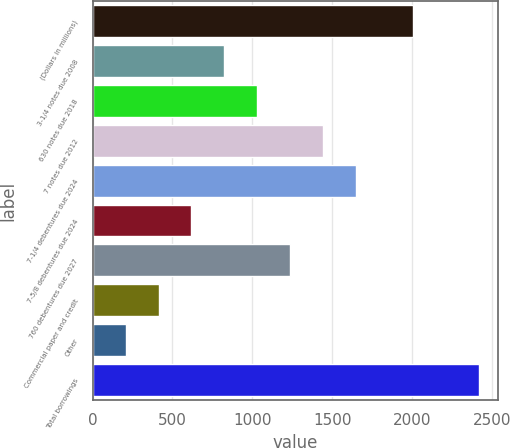<chart> <loc_0><loc_0><loc_500><loc_500><bar_chart><fcel>(Dollars in millions)<fcel>3-1/4 notes due 2008<fcel>630 notes due 2018<fcel>7 notes due 2012<fcel>7-1/4 debentures due 2024<fcel>7-5/8 debentures due 2024<fcel>760 debentures due 2027<fcel>Commercial paper and credit<fcel>Other<fcel>Total borrowings<nl><fcel>2004<fcel>825.4<fcel>1031.5<fcel>1443.7<fcel>1649.8<fcel>619.3<fcel>1237.6<fcel>413.2<fcel>207.1<fcel>2416.2<nl></chart> 